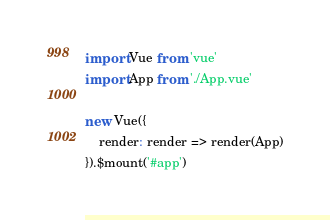<code> <loc_0><loc_0><loc_500><loc_500><_JavaScript_>import Vue from 'vue'
import App from './App.vue'

new Vue({
    render: render => render(App)
}).$mount('#app')
</code> 